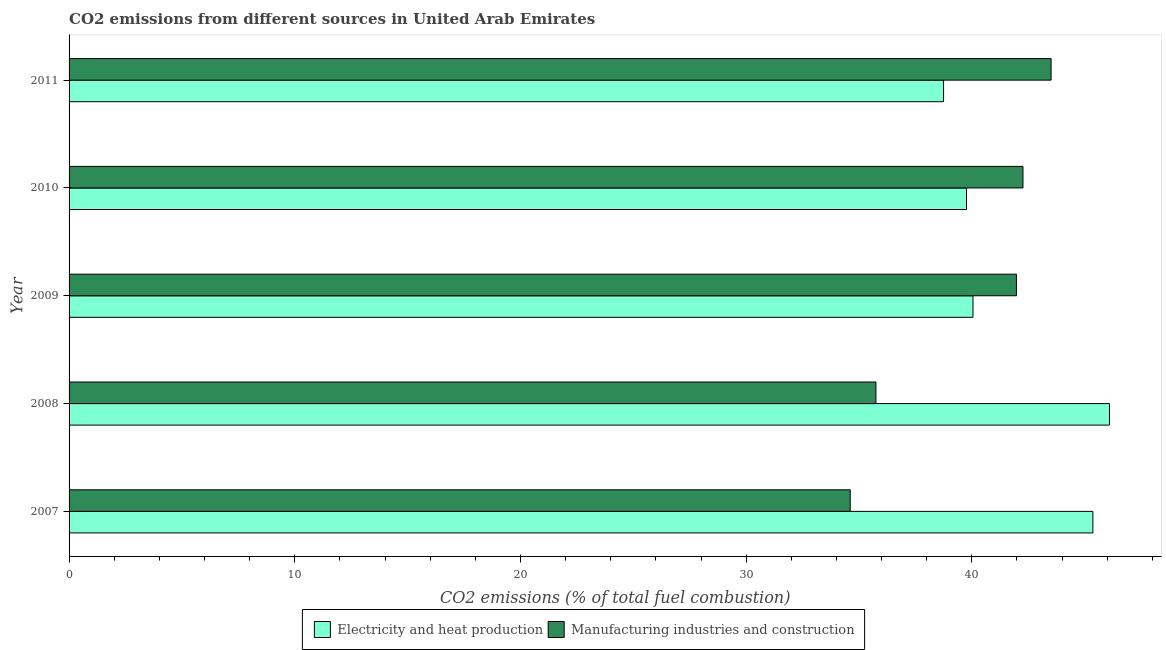How many different coloured bars are there?
Make the answer very short. 2. Are the number of bars on each tick of the Y-axis equal?
Provide a succinct answer. Yes. How many bars are there on the 2nd tick from the top?
Provide a succinct answer. 2. How many bars are there on the 4th tick from the bottom?
Offer a very short reply. 2. What is the co2 emissions due to electricity and heat production in 2011?
Provide a short and direct response. 38.75. Across all years, what is the maximum co2 emissions due to manufacturing industries?
Offer a very short reply. 43.51. Across all years, what is the minimum co2 emissions due to manufacturing industries?
Provide a short and direct response. 34.61. In which year was the co2 emissions due to electricity and heat production maximum?
Offer a terse response. 2008. In which year was the co2 emissions due to manufacturing industries minimum?
Keep it short and to the point. 2007. What is the total co2 emissions due to manufacturing industries in the graph?
Your answer should be compact. 198.12. What is the difference between the co2 emissions due to electricity and heat production in 2009 and the co2 emissions due to manufacturing industries in 2010?
Provide a succinct answer. -2.22. What is the average co2 emissions due to manufacturing industries per year?
Offer a very short reply. 39.62. In the year 2011, what is the difference between the co2 emissions due to manufacturing industries and co2 emissions due to electricity and heat production?
Provide a short and direct response. 4.76. In how many years, is the co2 emissions due to electricity and heat production greater than 32 %?
Your answer should be very brief. 5. What is the ratio of the co2 emissions due to electricity and heat production in 2007 to that in 2010?
Your response must be concise. 1.14. Is the difference between the co2 emissions due to manufacturing industries in 2007 and 2011 greater than the difference between the co2 emissions due to electricity and heat production in 2007 and 2011?
Offer a terse response. No. What is the difference between the highest and the second highest co2 emissions due to manufacturing industries?
Ensure brevity in your answer.  1.25. What is the difference between the highest and the lowest co2 emissions due to electricity and heat production?
Your response must be concise. 7.35. In how many years, is the co2 emissions due to electricity and heat production greater than the average co2 emissions due to electricity and heat production taken over all years?
Keep it short and to the point. 2. What does the 1st bar from the top in 2011 represents?
Keep it short and to the point. Manufacturing industries and construction. What does the 1st bar from the bottom in 2010 represents?
Your answer should be very brief. Electricity and heat production. Are all the bars in the graph horizontal?
Provide a succinct answer. Yes. What is the difference between two consecutive major ticks on the X-axis?
Your answer should be compact. 10. Does the graph contain any zero values?
Make the answer very short. No. How many legend labels are there?
Provide a succinct answer. 2. What is the title of the graph?
Keep it short and to the point. CO2 emissions from different sources in United Arab Emirates. What is the label or title of the X-axis?
Give a very brief answer. CO2 emissions (% of total fuel combustion). What is the label or title of the Y-axis?
Your answer should be very brief. Year. What is the CO2 emissions (% of total fuel combustion) of Electricity and heat production in 2007?
Your response must be concise. 45.36. What is the CO2 emissions (% of total fuel combustion) in Manufacturing industries and construction in 2007?
Your answer should be very brief. 34.61. What is the CO2 emissions (% of total fuel combustion) in Electricity and heat production in 2008?
Provide a short and direct response. 46.1. What is the CO2 emissions (% of total fuel combustion) in Manufacturing industries and construction in 2008?
Keep it short and to the point. 35.75. What is the CO2 emissions (% of total fuel combustion) in Electricity and heat production in 2009?
Your answer should be compact. 40.05. What is the CO2 emissions (% of total fuel combustion) of Manufacturing industries and construction in 2009?
Keep it short and to the point. 41.98. What is the CO2 emissions (% of total fuel combustion) of Electricity and heat production in 2010?
Provide a succinct answer. 39.76. What is the CO2 emissions (% of total fuel combustion) in Manufacturing industries and construction in 2010?
Your answer should be compact. 42.27. What is the CO2 emissions (% of total fuel combustion) of Electricity and heat production in 2011?
Keep it short and to the point. 38.75. What is the CO2 emissions (% of total fuel combustion) of Manufacturing industries and construction in 2011?
Your answer should be compact. 43.51. Across all years, what is the maximum CO2 emissions (% of total fuel combustion) of Electricity and heat production?
Keep it short and to the point. 46.1. Across all years, what is the maximum CO2 emissions (% of total fuel combustion) in Manufacturing industries and construction?
Your response must be concise. 43.51. Across all years, what is the minimum CO2 emissions (% of total fuel combustion) of Electricity and heat production?
Provide a short and direct response. 38.75. Across all years, what is the minimum CO2 emissions (% of total fuel combustion) in Manufacturing industries and construction?
Provide a short and direct response. 34.61. What is the total CO2 emissions (% of total fuel combustion) of Electricity and heat production in the graph?
Your answer should be compact. 210.03. What is the total CO2 emissions (% of total fuel combustion) of Manufacturing industries and construction in the graph?
Make the answer very short. 198.12. What is the difference between the CO2 emissions (% of total fuel combustion) in Electricity and heat production in 2007 and that in 2008?
Your answer should be compact. -0.74. What is the difference between the CO2 emissions (% of total fuel combustion) in Manufacturing industries and construction in 2007 and that in 2008?
Ensure brevity in your answer.  -1.14. What is the difference between the CO2 emissions (% of total fuel combustion) in Electricity and heat production in 2007 and that in 2009?
Your answer should be compact. 5.31. What is the difference between the CO2 emissions (% of total fuel combustion) of Manufacturing industries and construction in 2007 and that in 2009?
Keep it short and to the point. -7.36. What is the difference between the CO2 emissions (% of total fuel combustion) of Electricity and heat production in 2007 and that in 2010?
Provide a short and direct response. 5.6. What is the difference between the CO2 emissions (% of total fuel combustion) of Manufacturing industries and construction in 2007 and that in 2010?
Ensure brevity in your answer.  -7.65. What is the difference between the CO2 emissions (% of total fuel combustion) in Electricity and heat production in 2007 and that in 2011?
Provide a succinct answer. 6.62. What is the difference between the CO2 emissions (% of total fuel combustion) in Manufacturing industries and construction in 2007 and that in 2011?
Offer a terse response. -8.9. What is the difference between the CO2 emissions (% of total fuel combustion) of Electricity and heat production in 2008 and that in 2009?
Your answer should be very brief. 6.05. What is the difference between the CO2 emissions (% of total fuel combustion) in Manufacturing industries and construction in 2008 and that in 2009?
Make the answer very short. -6.23. What is the difference between the CO2 emissions (% of total fuel combustion) of Electricity and heat production in 2008 and that in 2010?
Keep it short and to the point. 6.33. What is the difference between the CO2 emissions (% of total fuel combustion) of Manufacturing industries and construction in 2008 and that in 2010?
Offer a terse response. -6.52. What is the difference between the CO2 emissions (% of total fuel combustion) in Electricity and heat production in 2008 and that in 2011?
Offer a very short reply. 7.35. What is the difference between the CO2 emissions (% of total fuel combustion) of Manufacturing industries and construction in 2008 and that in 2011?
Offer a very short reply. -7.76. What is the difference between the CO2 emissions (% of total fuel combustion) of Electricity and heat production in 2009 and that in 2010?
Provide a succinct answer. 0.29. What is the difference between the CO2 emissions (% of total fuel combustion) of Manufacturing industries and construction in 2009 and that in 2010?
Offer a very short reply. -0.29. What is the difference between the CO2 emissions (% of total fuel combustion) of Electricity and heat production in 2009 and that in 2011?
Offer a very short reply. 1.3. What is the difference between the CO2 emissions (% of total fuel combustion) in Manufacturing industries and construction in 2009 and that in 2011?
Your answer should be compact. -1.54. What is the difference between the CO2 emissions (% of total fuel combustion) of Electricity and heat production in 2010 and that in 2011?
Your answer should be very brief. 1.02. What is the difference between the CO2 emissions (% of total fuel combustion) of Manufacturing industries and construction in 2010 and that in 2011?
Provide a short and direct response. -1.25. What is the difference between the CO2 emissions (% of total fuel combustion) of Electricity and heat production in 2007 and the CO2 emissions (% of total fuel combustion) of Manufacturing industries and construction in 2008?
Offer a very short reply. 9.61. What is the difference between the CO2 emissions (% of total fuel combustion) of Electricity and heat production in 2007 and the CO2 emissions (% of total fuel combustion) of Manufacturing industries and construction in 2009?
Make the answer very short. 3.39. What is the difference between the CO2 emissions (% of total fuel combustion) in Electricity and heat production in 2007 and the CO2 emissions (% of total fuel combustion) in Manufacturing industries and construction in 2010?
Ensure brevity in your answer.  3.1. What is the difference between the CO2 emissions (% of total fuel combustion) of Electricity and heat production in 2007 and the CO2 emissions (% of total fuel combustion) of Manufacturing industries and construction in 2011?
Provide a short and direct response. 1.85. What is the difference between the CO2 emissions (% of total fuel combustion) in Electricity and heat production in 2008 and the CO2 emissions (% of total fuel combustion) in Manufacturing industries and construction in 2009?
Make the answer very short. 4.12. What is the difference between the CO2 emissions (% of total fuel combustion) of Electricity and heat production in 2008 and the CO2 emissions (% of total fuel combustion) of Manufacturing industries and construction in 2010?
Provide a short and direct response. 3.83. What is the difference between the CO2 emissions (% of total fuel combustion) in Electricity and heat production in 2008 and the CO2 emissions (% of total fuel combustion) in Manufacturing industries and construction in 2011?
Keep it short and to the point. 2.59. What is the difference between the CO2 emissions (% of total fuel combustion) of Electricity and heat production in 2009 and the CO2 emissions (% of total fuel combustion) of Manufacturing industries and construction in 2010?
Provide a succinct answer. -2.22. What is the difference between the CO2 emissions (% of total fuel combustion) of Electricity and heat production in 2009 and the CO2 emissions (% of total fuel combustion) of Manufacturing industries and construction in 2011?
Your response must be concise. -3.46. What is the difference between the CO2 emissions (% of total fuel combustion) in Electricity and heat production in 2010 and the CO2 emissions (% of total fuel combustion) in Manufacturing industries and construction in 2011?
Give a very brief answer. -3.75. What is the average CO2 emissions (% of total fuel combustion) in Electricity and heat production per year?
Make the answer very short. 42.01. What is the average CO2 emissions (% of total fuel combustion) of Manufacturing industries and construction per year?
Ensure brevity in your answer.  39.62. In the year 2007, what is the difference between the CO2 emissions (% of total fuel combustion) of Electricity and heat production and CO2 emissions (% of total fuel combustion) of Manufacturing industries and construction?
Provide a short and direct response. 10.75. In the year 2008, what is the difference between the CO2 emissions (% of total fuel combustion) of Electricity and heat production and CO2 emissions (% of total fuel combustion) of Manufacturing industries and construction?
Make the answer very short. 10.35. In the year 2009, what is the difference between the CO2 emissions (% of total fuel combustion) in Electricity and heat production and CO2 emissions (% of total fuel combustion) in Manufacturing industries and construction?
Provide a short and direct response. -1.93. In the year 2010, what is the difference between the CO2 emissions (% of total fuel combustion) in Electricity and heat production and CO2 emissions (% of total fuel combustion) in Manufacturing industries and construction?
Give a very brief answer. -2.5. In the year 2011, what is the difference between the CO2 emissions (% of total fuel combustion) in Electricity and heat production and CO2 emissions (% of total fuel combustion) in Manufacturing industries and construction?
Your answer should be compact. -4.76. What is the ratio of the CO2 emissions (% of total fuel combustion) in Electricity and heat production in 2007 to that in 2008?
Provide a succinct answer. 0.98. What is the ratio of the CO2 emissions (% of total fuel combustion) in Manufacturing industries and construction in 2007 to that in 2008?
Ensure brevity in your answer.  0.97. What is the ratio of the CO2 emissions (% of total fuel combustion) in Electricity and heat production in 2007 to that in 2009?
Provide a short and direct response. 1.13. What is the ratio of the CO2 emissions (% of total fuel combustion) in Manufacturing industries and construction in 2007 to that in 2009?
Offer a very short reply. 0.82. What is the ratio of the CO2 emissions (% of total fuel combustion) in Electricity and heat production in 2007 to that in 2010?
Keep it short and to the point. 1.14. What is the ratio of the CO2 emissions (% of total fuel combustion) of Manufacturing industries and construction in 2007 to that in 2010?
Give a very brief answer. 0.82. What is the ratio of the CO2 emissions (% of total fuel combustion) of Electricity and heat production in 2007 to that in 2011?
Provide a succinct answer. 1.17. What is the ratio of the CO2 emissions (% of total fuel combustion) in Manufacturing industries and construction in 2007 to that in 2011?
Provide a short and direct response. 0.8. What is the ratio of the CO2 emissions (% of total fuel combustion) in Electricity and heat production in 2008 to that in 2009?
Make the answer very short. 1.15. What is the ratio of the CO2 emissions (% of total fuel combustion) of Manufacturing industries and construction in 2008 to that in 2009?
Your response must be concise. 0.85. What is the ratio of the CO2 emissions (% of total fuel combustion) in Electricity and heat production in 2008 to that in 2010?
Offer a terse response. 1.16. What is the ratio of the CO2 emissions (% of total fuel combustion) in Manufacturing industries and construction in 2008 to that in 2010?
Make the answer very short. 0.85. What is the ratio of the CO2 emissions (% of total fuel combustion) in Electricity and heat production in 2008 to that in 2011?
Offer a very short reply. 1.19. What is the ratio of the CO2 emissions (% of total fuel combustion) in Manufacturing industries and construction in 2008 to that in 2011?
Ensure brevity in your answer.  0.82. What is the ratio of the CO2 emissions (% of total fuel combustion) of Electricity and heat production in 2009 to that in 2010?
Ensure brevity in your answer.  1.01. What is the ratio of the CO2 emissions (% of total fuel combustion) in Manufacturing industries and construction in 2009 to that in 2010?
Give a very brief answer. 0.99. What is the ratio of the CO2 emissions (% of total fuel combustion) of Electricity and heat production in 2009 to that in 2011?
Provide a succinct answer. 1.03. What is the ratio of the CO2 emissions (% of total fuel combustion) in Manufacturing industries and construction in 2009 to that in 2011?
Your answer should be very brief. 0.96. What is the ratio of the CO2 emissions (% of total fuel combustion) of Electricity and heat production in 2010 to that in 2011?
Offer a terse response. 1.03. What is the ratio of the CO2 emissions (% of total fuel combustion) in Manufacturing industries and construction in 2010 to that in 2011?
Make the answer very short. 0.97. What is the difference between the highest and the second highest CO2 emissions (% of total fuel combustion) of Electricity and heat production?
Provide a succinct answer. 0.74. What is the difference between the highest and the second highest CO2 emissions (% of total fuel combustion) in Manufacturing industries and construction?
Provide a succinct answer. 1.25. What is the difference between the highest and the lowest CO2 emissions (% of total fuel combustion) in Electricity and heat production?
Offer a terse response. 7.35. What is the difference between the highest and the lowest CO2 emissions (% of total fuel combustion) of Manufacturing industries and construction?
Your answer should be very brief. 8.9. 